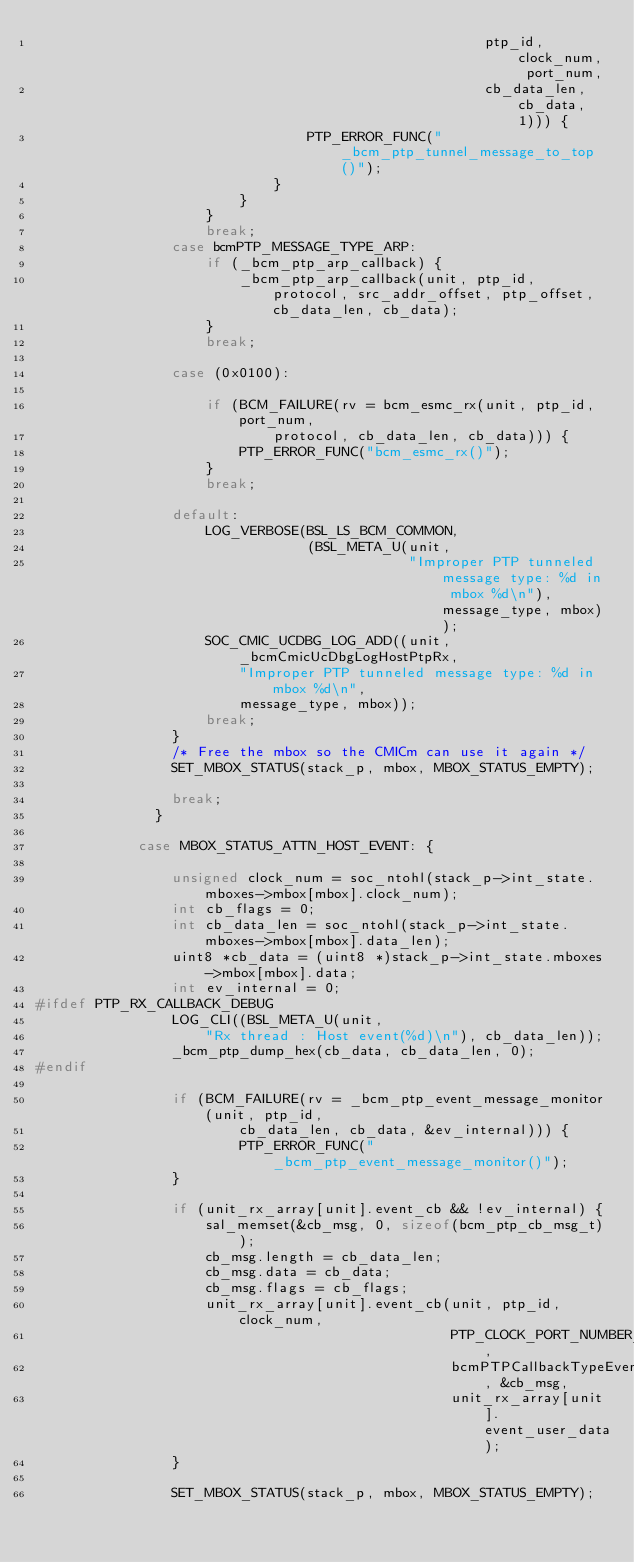<code> <loc_0><loc_0><loc_500><loc_500><_C_>                                                     ptp_id, clock_num, port_num,
                                                     cb_data_len, cb_data, 1))) {
                                PTP_ERROR_FUNC("_bcm_ptp_tunnel_message_to_top()");
                            }
                        }
                    }
                    break;
                case bcmPTP_MESSAGE_TYPE_ARP:
                    if (_bcm_ptp_arp_callback) {
                        _bcm_ptp_arp_callback(unit, ptp_id, protocol, src_addr_offset, ptp_offset, cb_data_len, cb_data);
                    }
                    break;

                case (0x0100):
                    
                    if (BCM_FAILURE(rv = bcm_esmc_rx(unit, ptp_id, port_num,
                            protocol, cb_data_len, cb_data))) {
                        PTP_ERROR_FUNC("bcm_esmc_rx()");
                    }
                    break;

                default:
                    LOG_VERBOSE(BSL_LS_BCM_COMMON,
                                (BSL_META_U(unit,
                                            "Improper PTP tunneled message type: %d in mbox %d\n"), message_type, mbox));
                    SOC_CMIC_UCDBG_LOG_ADD((unit, _bcmCmicUcDbgLogHostPtpRx,
                        "Improper PTP tunneled message type: %d in mbox %d\n",
                        message_type, mbox));
                    break;
                }
                /* Free the mbox so the CMICm can use it again */
                SET_MBOX_STATUS(stack_p, mbox, MBOX_STATUS_EMPTY);

                break;
              }

            case MBOX_STATUS_ATTN_HOST_EVENT: {
                
                unsigned clock_num = soc_ntohl(stack_p->int_state.mboxes->mbox[mbox].clock_num);
                int cb_flags = 0;
                int cb_data_len = soc_ntohl(stack_p->int_state.mboxes->mbox[mbox].data_len);
                uint8 *cb_data = (uint8 *)stack_p->int_state.mboxes->mbox[mbox].data;
                int ev_internal = 0;
#ifdef PTP_RX_CALLBACK_DEBUG
                LOG_CLI((BSL_META_U(unit,
                    "Rx thread : Host event(%d)\n"), cb_data_len));
                _bcm_ptp_dump_hex(cb_data, cb_data_len, 0);
#endif

                if (BCM_FAILURE(rv = _bcm_ptp_event_message_monitor(unit, ptp_id,
                        cb_data_len, cb_data, &ev_internal))) {
                        PTP_ERROR_FUNC("_bcm_ptp_event_message_monitor()");
                }

                if (unit_rx_array[unit].event_cb && !ev_internal) {
                    sal_memset(&cb_msg, 0, sizeof(bcm_ptp_cb_msg_t));
                    cb_msg.length = cb_data_len;
                    cb_msg.data = cb_data;
                    cb_msg.flags = cb_flags;
                    unit_rx_array[unit].event_cb(unit, ptp_id, clock_num,
                                                 PTP_CLOCK_PORT_NUMBER_DEFAULT,
                                                 bcmPTPCallbackTypeEvent, &cb_msg,
                                                 unit_rx_array[unit].event_user_data);
                }

                SET_MBOX_STATUS(stack_p, mbox, MBOX_STATUS_EMPTY);</code> 